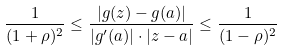Convert formula to latex. <formula><loc_0><loc_0><loc_500><loc_500>\frac { 1 } { ( 1 + \rho ) ^ { 2 } } \leq \frac { | g ( z ) - g ( a ) | } { | g ^ { \prime } ( a ) | \cdot | z - a | } \leq \frac { 1 } { ( 1 - \rho ) ^ { 2 } }</formula> 